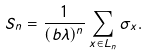Convert formula to latex. <formula><loc_0><loc_0><loc_500><loc_500>S _ { n } = \frac { 1 } { ( b \lambda ) ^ { n } } \sum _ { x \in L _ { n } } \sigma _ { x } .</formula> 